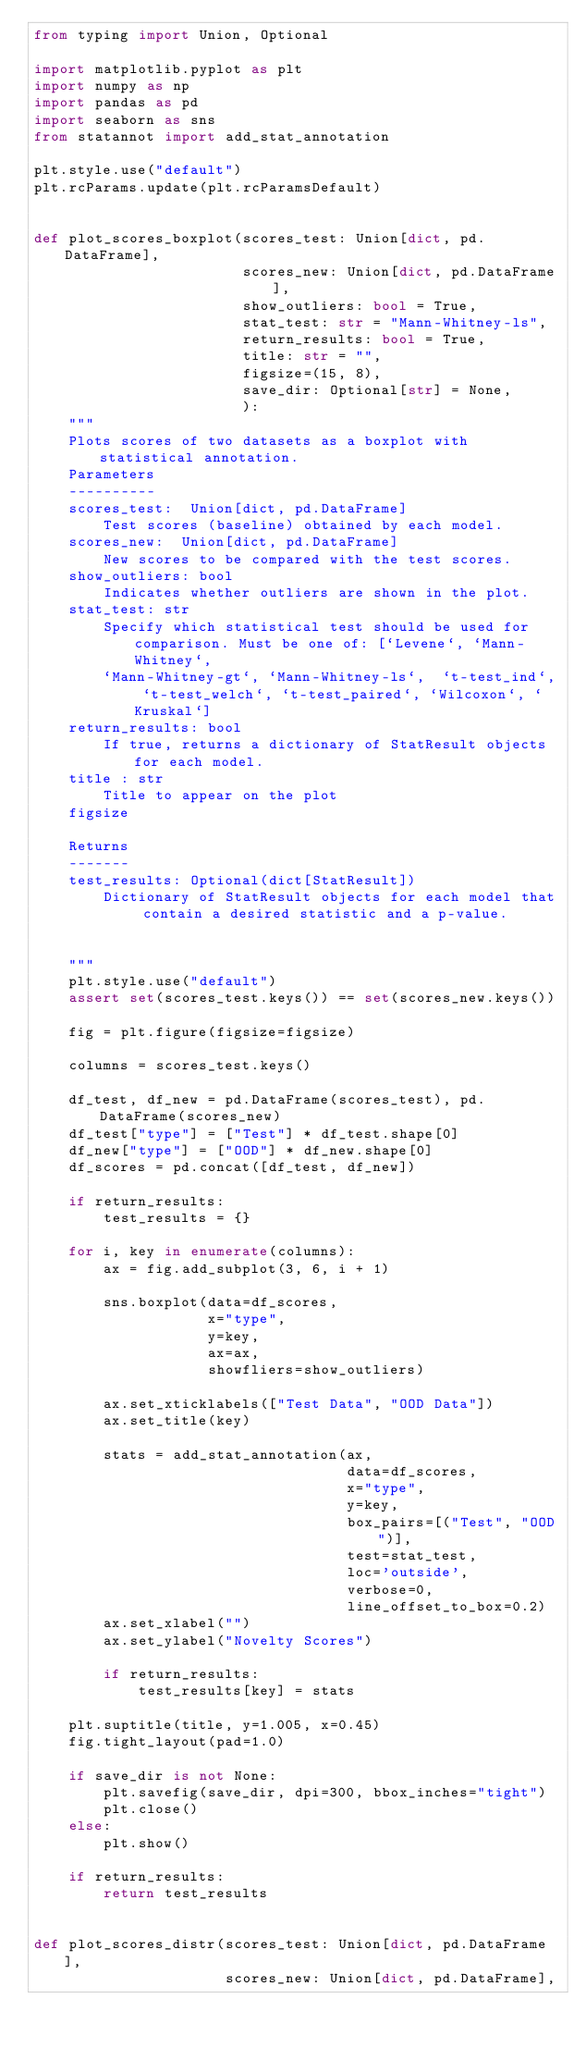Convert code to text. <code><loc_0><loc_0><loc_500><loc_500><_Python_>from typing import Union, Optional

import matplotlib.pyplot as plt
import numpy as np
import pandas as pd
import seaborn as sns
from statannot import add_stat_annotation

plt.style.use("default")
plt.rcParams.update(plt.rcParamsDefault)


def plot_scores_boxplot(scores_test: Union[dict, pd.DataFrame],
                        scores_new: Union[dict, pd.DataFrame],
                        show_outliers: bool = True,
                        stat_test: str = "Mann-Whitney-ls",
                        return_results: bool = True,
                        title: str = "",
                        figsize=(15, 8),
                        save_dir: Optional[str] = None,
                        ):
    """
    Plots scores of two datasets as a boxplot with statistical annotation.
    Parameters
    ----------
    scores_test:  Union[dict, pd.DataFrame]
        Test scores (baseline) obtained by each model.
    scores_new:  Union[dict, pd.DataFrame]
        New scores to be compared with the test scores.
    show_outliers: bool
        Indicates whether outliers are shown in the plot.
    stat_test: str
        Specify which statistical test should be used for comparison. Must be one of: [`Levene`, `Mann-Whitney`,
        `Mann-Whitney-gt`, `Mann-Whitney-ls`,  `t-test_ind`, `t-test_welch`, `t-test_paired`, `Wilcoxon`, `Kruskal`]
    return_results: bool
        If true, returns a dictionary of StatResult objects for each model.
    title : str
        Title to appear on the plot
    figsize

    Returns
    -------
    test_results: Optional(dict[StatResult])
        Dictionary of StatResult objects for each model that contain a desired statistic and a p-value.


    """
    plt.style.use("default")
    assert set(scores_test.keys()) == set(scores_new.keys())

    fig = plt.figure(figsize=figsize)

    columns = scores_test.keys()

    df_test, df_new = pd.DataFrame(scores_test), pd.DataFrame(scores_new)
    df_test["type"] = ["Test"] * df_test.shape[0]
    df_new["type"] = ["OOD"] * df_new.shape[0]
    df_scores = pd.concat([df_test, df_new])

    if return_results:
        test_results = {}

    for i, key in enumerate(columns):
        ax = fig.add_subplot(3, 6, i + 1)

        sns.boxplot(data=df_scores,
                    x="type",
                    y=key,
                    ax=ax,
                    showfliers=show_outliers)

        ax.set_xticklabels(["Test Data", "OOD Data"])
        ax.set_title(key)

        stats = add_stat_annotation(ax,
                                    data=df_scores,
                                    x="type",
                                    y=key,
                                    box_pairs=[("Test", "OOD")],
                                    test=stat_test,
                                    loc='outside',
                                    verbose=0,
                                    line_offset_to_box=0.2)
        ax.set_xlabel("")
        ax.set_ylabel("Novelty Scores")

        if return_results:
            test_results[key] = stats

    plt.suptitle(title, y=1.005, x=0.45)
    fig.tight_layout(pad=1.0)

    if save_dir is not None:
        plt.savefig(save_dir, dpi=300, bbox_inches="tight")
        plt.close()
    else:
        plt.show()

    if return_results:
        return test_results


def plot_scores_distr(scores_test: Union[dict, pd.DataFrame],
                      scores_new: Union[dict, pd.DataFrame],</code> 